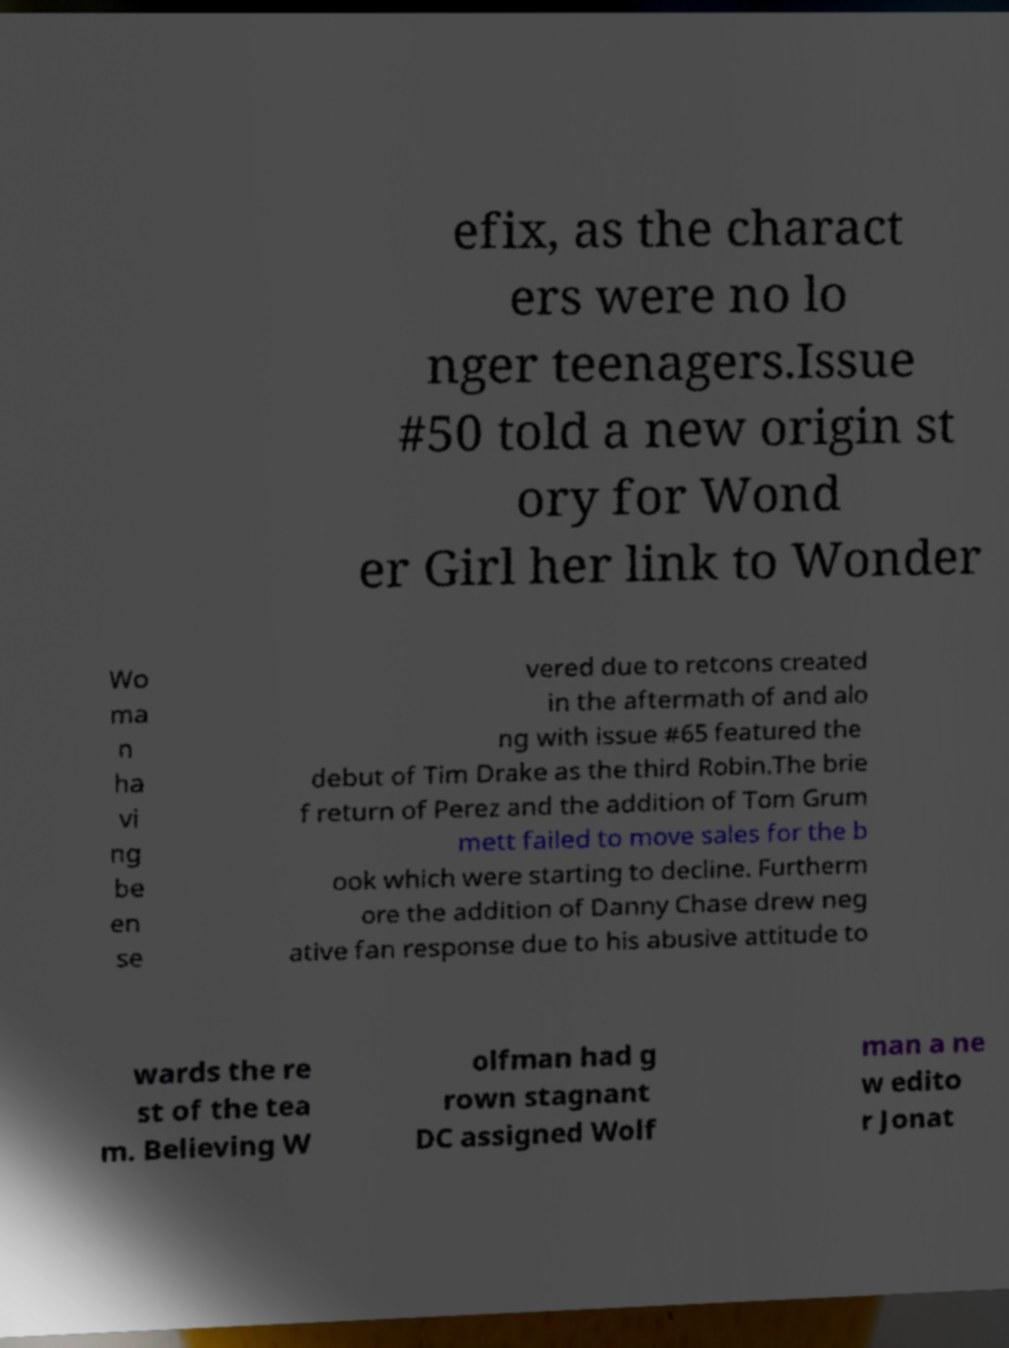There's text embedded in this image that I need extracted. Can you transcribe it verbatim? efix, as the charact ers were no lo nger teenagers.Issue #50 told a new origin st ory for Wond er Girl her link to Wonder Wo ma n ha vi ng be en se vered due to retcons created in the aftermath of and alo ng with issue #65 featured the debut of Tim Drake as the third Robin.The brie f return of Perez and the addition of Tom Grum mett failed to move sales for the b ook which were starting to decline. Furtherm ore the addition of Danny Chase drew neg ative fan response due to his abusive attitude to wards the re st of the tea m. Believing W olfman had g rown stagnant DC assigned Wolf man a ne w edito r Jonat 